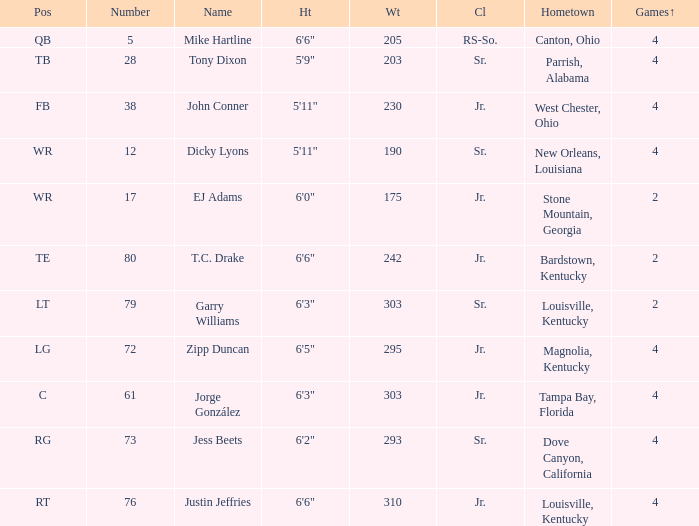Which Class has a Weight of 203? Sr. 